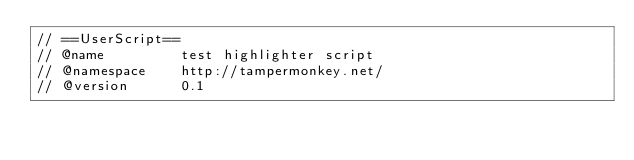Convert code to text. <code><loc_0><loc_0><loc_500><loc_500><_JavaScript_>// ==UserScript==
// @name         test highlighter script
// @namespace    http://tampermonkey.net/
// @version      0.1</code> 